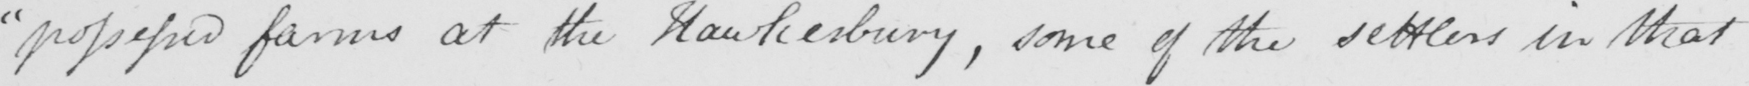Can you tell me what this handwritten text says? " possessed farms at the Hawkesbury , some of the settlers in that 